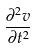<formula> <loc_0><loc_0><loc_500><loc_500>\frac { \partial ^ { 2 } v } { \partial t ^ { 2 } }</formula> 